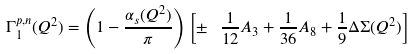<formula> <loc_0><loc_0><loc_500><loc_500>\Gamma _ { 1 } ^ { p , n } ( Q ^ { 2 } ) = \left ( 1 - \frac { \alpha _ { s } ( Q ^ { 2 } ) } { \pi } \right ) \left [ \pm \ \, \frac { 1 } { 1 2 } A _ { 3 } + \frac { 1 } { 3 6 } A _ { 8 } + \frac { 1 } { 9 } \Delta \Sigma ( Q ^ { 2 } ) \right ]</formula> 